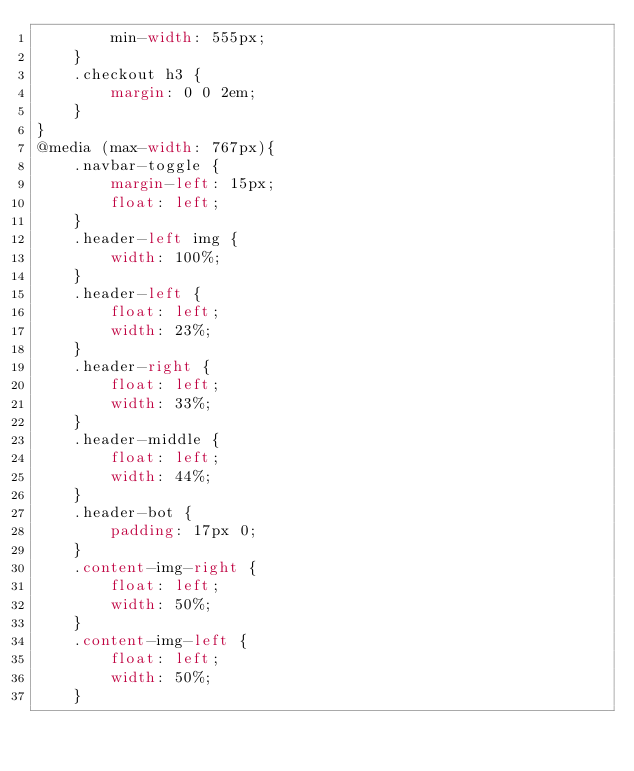Convert code to text. <code><loc_0><loc_0><loc_500><loc_500><_CSS_>		min-width: 555px;
	}
	.checkout h3 {
		margin: 0 0 2em;
	}	
}
@media (max-width: 767px){
	.navbar-toggle {
		margin-left: 15px;
		float: left;
	}
	.header-left img {
		width: 100%;
	}
	.header-left {
		float: left;
		width: 23%;
	}
	.header-right {
		float: left;
		width: 33%;
	}
	.header-middle {
		float: left;
		width: 44%;
	}
	.header-bot {
		padding: 17px 0;
	}
	.content-img-right {
		float: left;
		width: 50%;
	}
	.content-img-left {
		float: left;
		width: 50%;
	}</code> 